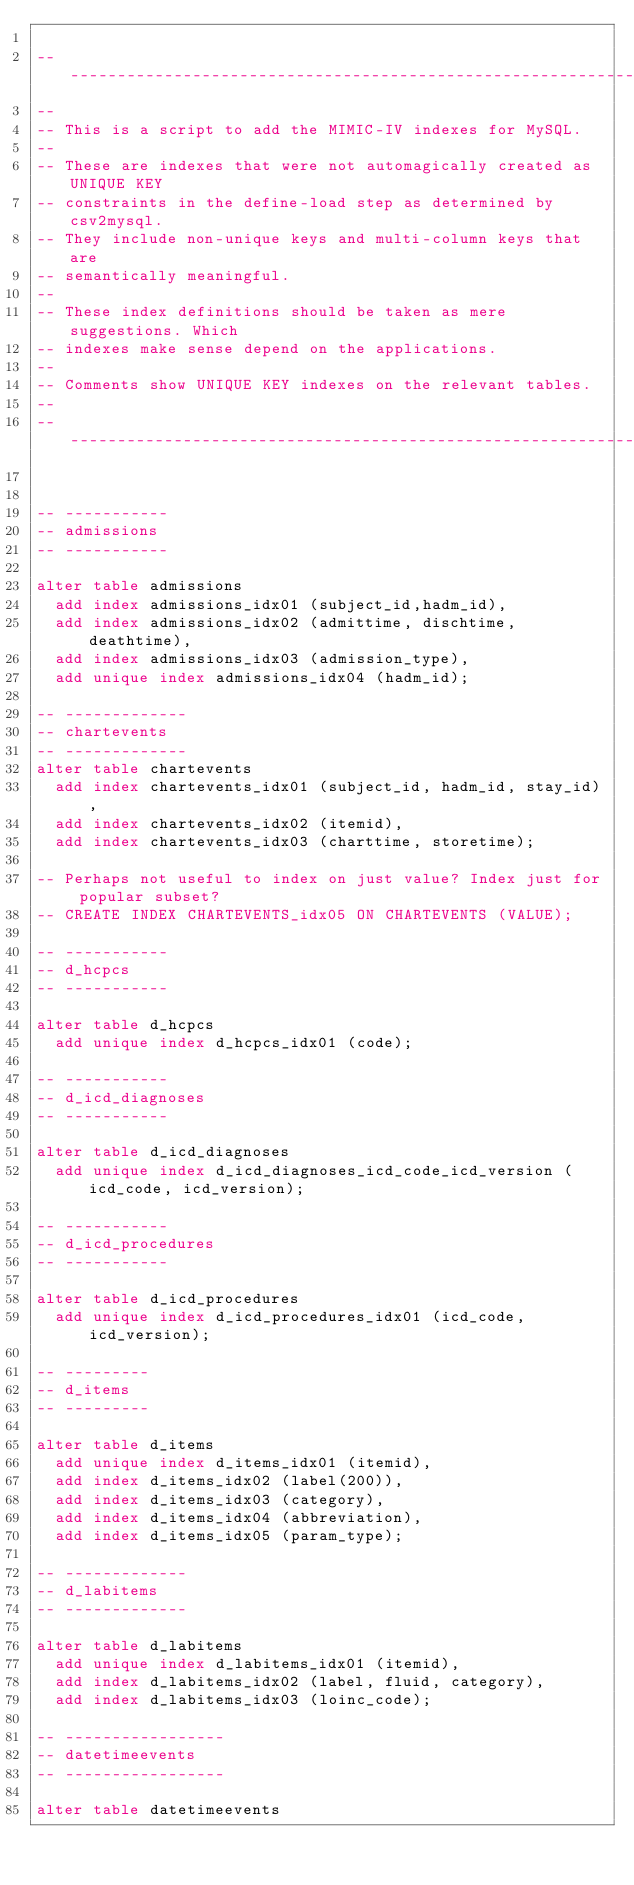<code> <loc_0><loc_0><loc_500><loc_500><_SQL_>
-- ----------------------------------------------------------------
--
-- This is a script to add the MIMIC-IV indexes for MySQL.
--
-- These are indexes that were not automagically created as UNIQUE KEY
-- constraints in the define-load step as determined by csv2mysql.
-- They include non-unique keys and multi-column keys that are
-- semantically meaningful.
--
-- These index definitions should be taken as mere suggestions. Which
-- indexes make sense depend on the applications.
--
-- Comments show UNIQUE KEY indexes on the relevant tables.
-- 
-- ----------------------------------------------------------------


-- -----------
-- admissions
-- -----------

alter table admissions
  add index admissions_idx01 (subject_id,hadm_id),
  add index admissions_idx02 (admittime, dischtime, deathtime),
  add index admissions_idx03 (admission_type),
  add unique index admissions_idx04 (hadm_id);

-- -------------
-- chartevents
-- -------------
alter table chartevents 
  add index chartevents_idx01 (subject_id, hadm_id, stay_id),
  add index chartevents_idx02 (itemid),
  add index chartevents_idx03 (charttime, storetime);

-- Perhaps not useful to index on just value? Index just for popular subset?
-- CREATE INDEX CHARTEVENTS_idx05 ON CHARTEVENTS (VALUE);

-- -----------
-- d_hcpcs
-- -----------

alter table d_hcpcs
  add unique index d_hcpcs_idx01 (code);

-- -----------
-- d_icd_diagnoses
-- -----------

alter table d_icd_diagnoses
  add unique index d_icd_diagnoses_icd_code_icd_version (icd_code, icd_version);

-- -----------
-- d_icd_procedures
-- -----------

alter table d_icd_procedures
  add unique index d_icd_procedures_idx01 (icd_code, icd_version);

-- ---------
-- d_items
-- ---------

alter table d_items
  add unique index d_items_idx01 (itemid),
  add index d_items_idx02 (label(200)),
  add index d_items_idx03 (category),
  add index d_items_idx04 (abbreviation),
  add index d_items_idx05 (param_type);

-- -------------
-- d_labitems
-- -------------

alter table d_labitems
  add unique index d_labitems_idx01 (itemid),
  add index d_labitems_idx02 (label, fluid, category),
  add index d_labitems_idx03 (loinc_code);

-- -----------------
-- datetimeevents
-- -----------------

alter table datetimeevents</code> 